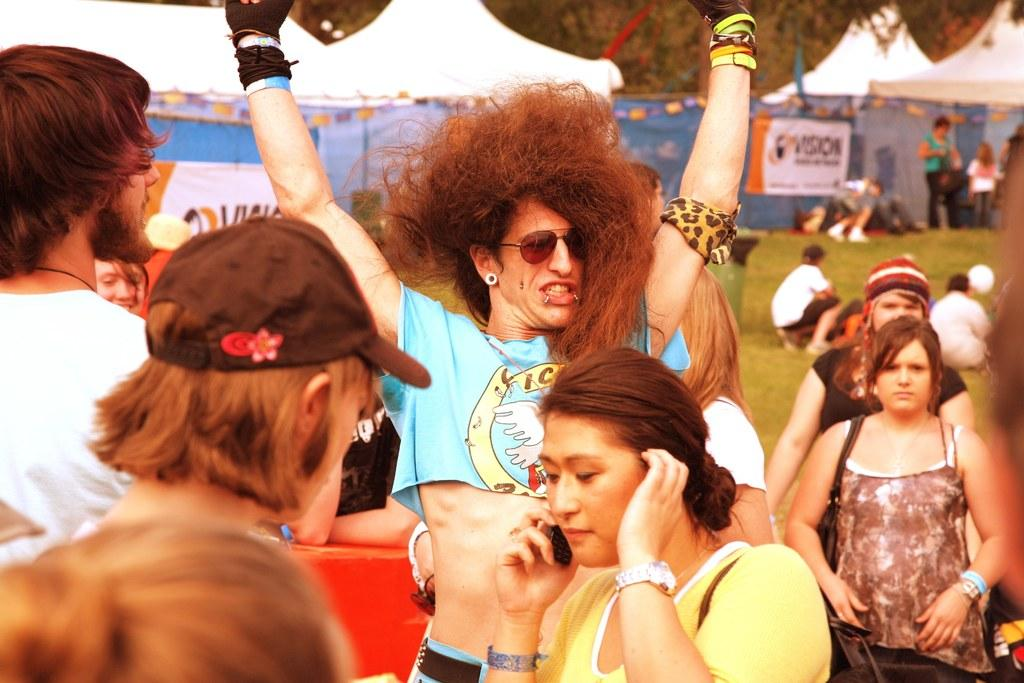How many people are in the image? There is a group of people in the image, but the exact number cannot be determined from the provided facts. What can be seen in the background of the image? There is grass visible in the background of the image. What type of jam is being spread on the grass in the image? There is no jam or any food item mentioned in the image; it only features a group of people and grass in the background. 